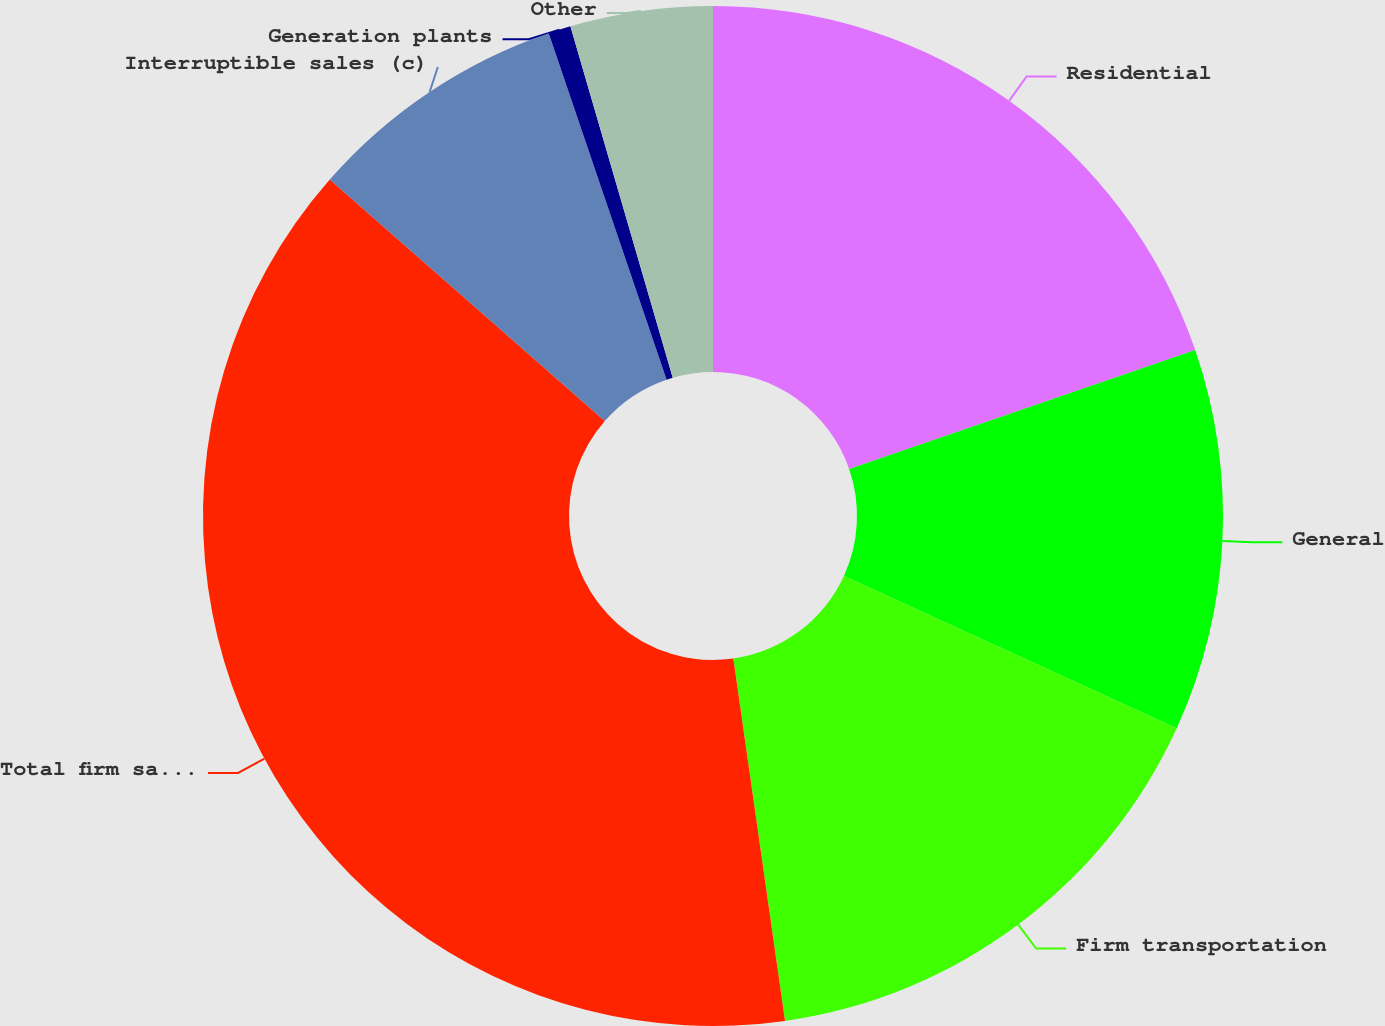Convert chart. <chart><loc_0><loc_0><loc_500><loc_500><pie_chart><fcel>Residential<fcel>General<fcel>Firm transportation<fcel>Total firm sales and<fcel>Interruptible sales (c)<fcel>Generation plants<fcel>Other<nl><fcel>19.72%<fcel>12.11%<fcel>15.91%<fcel>38.72%<fcel>8.31%<fcel>0.71%<fcel>4.51%<nl></chart> 